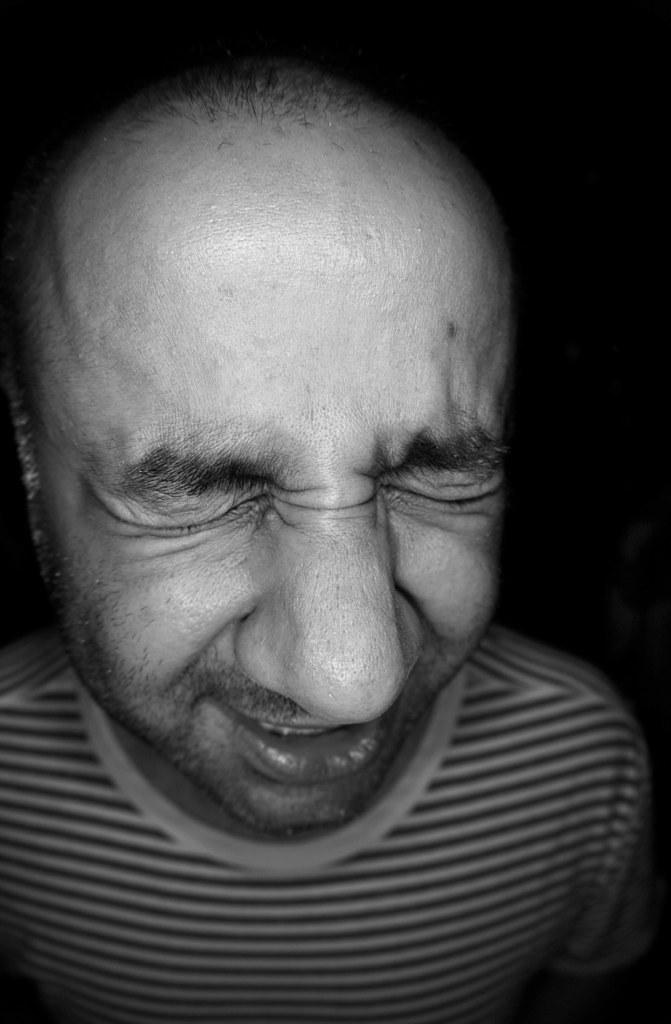What is the color scheme of the image? The image is black and white. Can you describe the person in the image? There is a man in the image. Where is the sofa located in the image? There is no sofa present in the image. What time of day is it in the image? The image does not provide any information about the time of day, as it is black and white and does not include any clues about the time. 